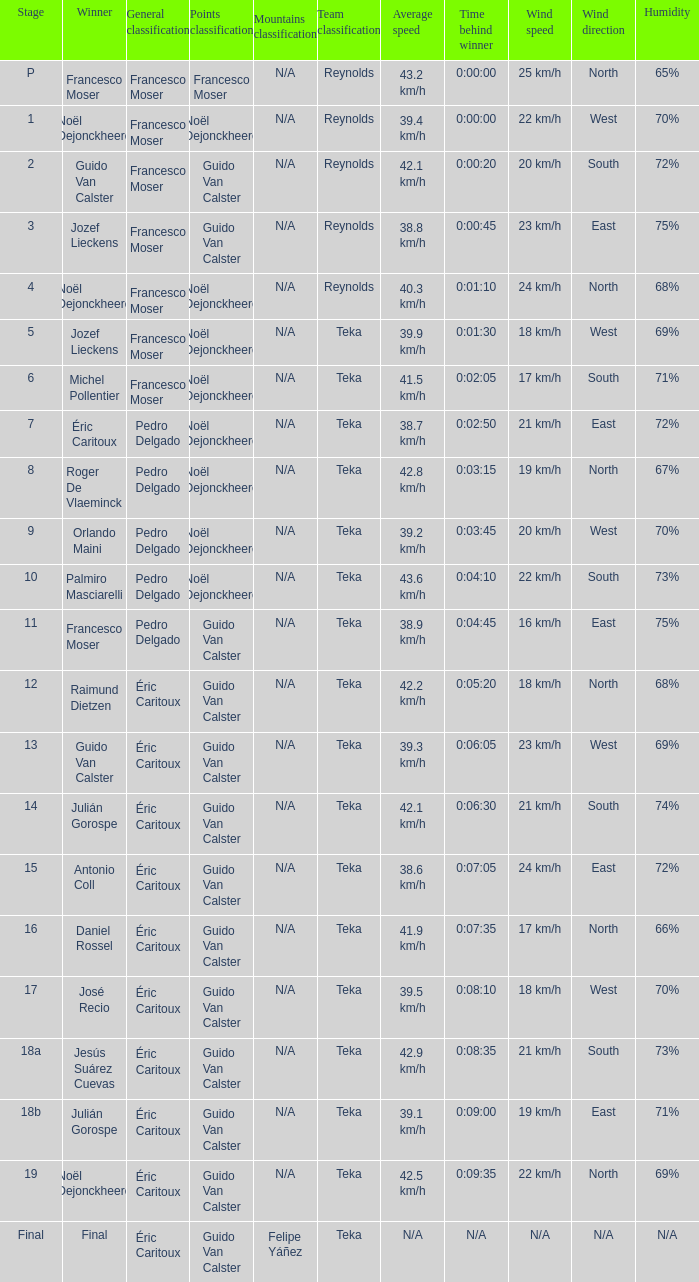Name the points classification for stage of 18b Guido Van Calster. 